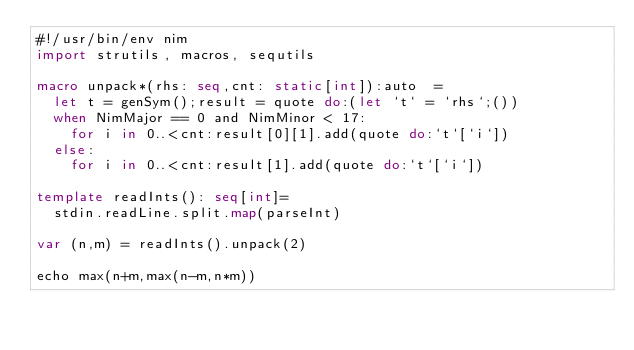<code> <loc_0><loc_0><loc_500><loc_500><_Nim_>#!/usr/bin/env nim
import strutils, macros, sequtils

macro unpack*(rhs: seq,cnt: static[int]):auto  =
  let t = genSym();result = quote do:(let `t` = `rhs`;())
  when NimMajor == 0 and NimMinor < 17:
    for i in 0..<cnt:result[0][1].add(quote do:`t`[`i`])
  else:
    for i in 0..<cnt:result[1].add(quote do:`t`[`i`])

template readInts(): seq[int]=
  stdin.readLine.split.map(parseInt)

var (n,m) = readInts().unpack(2)

echo max(n+m,max(n-m,n*m))</code> 